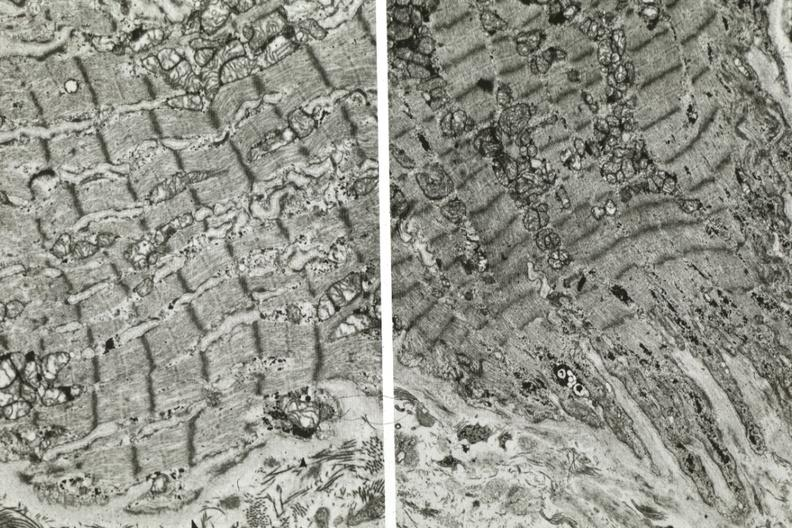what does this image show?
Answer the question using a single word or phrase. Electron micrographs demonstrating fiber not connect with another fiber other frame shows dilated sarcoplasmic reticulum 